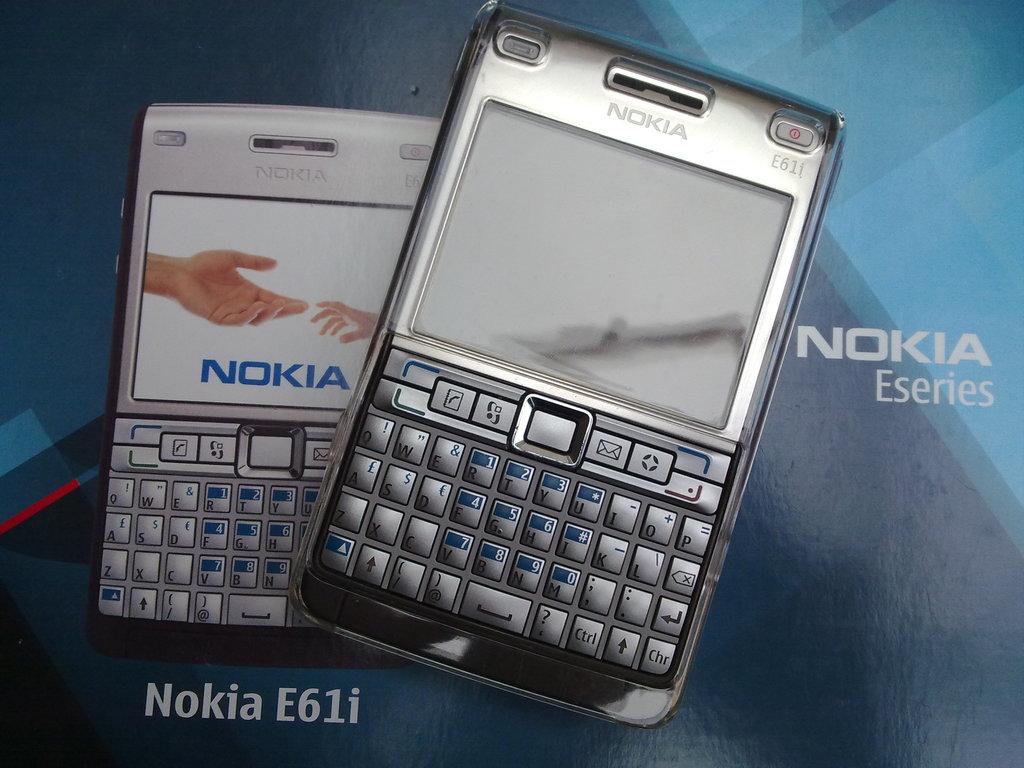What type of phones are these?
Provide a short and direct response. Nokia. What brand of phones are these?
Your answer should be very brief. Nokia. 